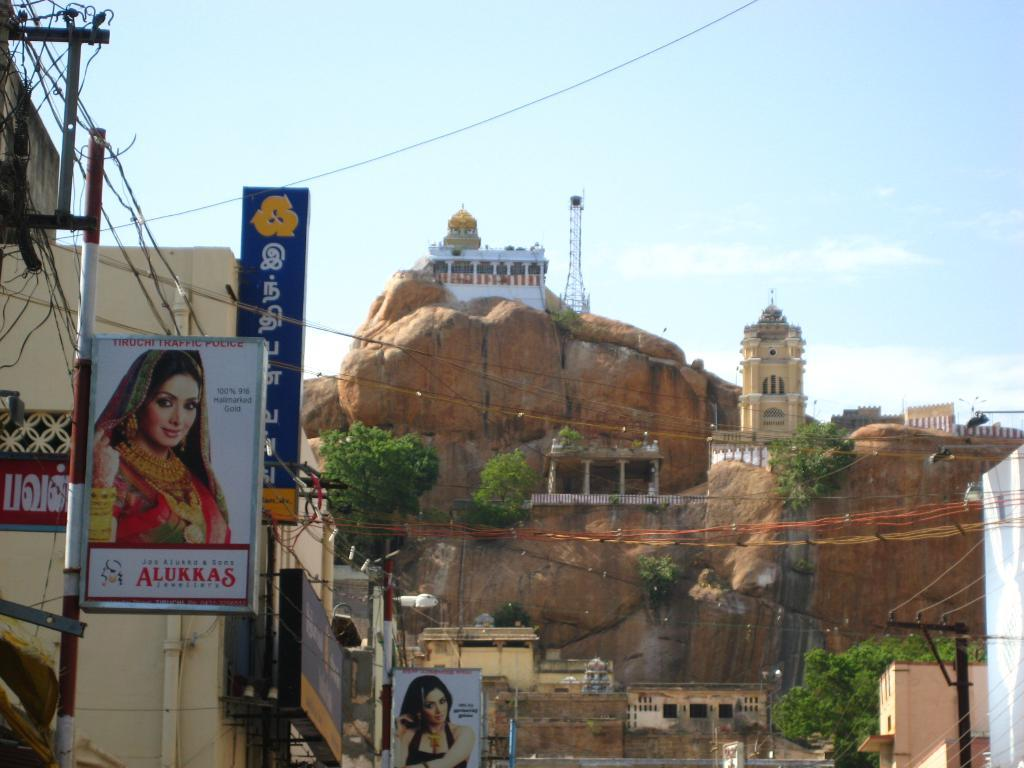What type of natural elements can be seen in the image? There are trees in the image. What man-made structures are present in the image? There are boards, poles, houses, lights, cables, and a cell tower in the image. What type of terrain is visible in the image? There are rocks in the image. What can be seen in the background of the image? The sky is visible in the background of the image. What type of advice can be seen written on the boards in the image? There is no advice written on the boards in the image; they are just plain boards. What shape is the square pipe in the image? There is no square pipe present in the image. 